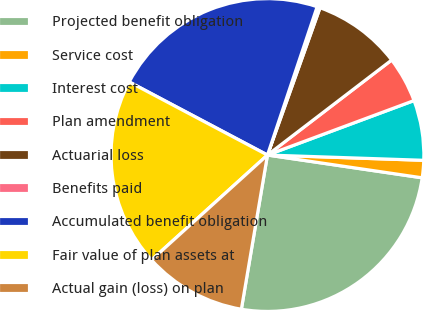<chart> <loc_0><loc_0><loc_500><loc_500><pie_chart><fcel>Projected benefit obligation<fcel>Service cost<fcel>Interest cost<fcel>Plan amendment<fcel>Actuarial loss<fcel>Benefits paid<fcel>Accumulated benefit obligation<fcel>Fair value of plan assets at<fcel>Actual gain (loss) on plan<nl><fcel>25.34%<fcel>1.79%<fcel>6.2%<fcel>4.73%<fcel>9.15%<fcel>0.31%<fcel>22.4%<fcel>19.45%<fcel>10.62%<nl></chart> 